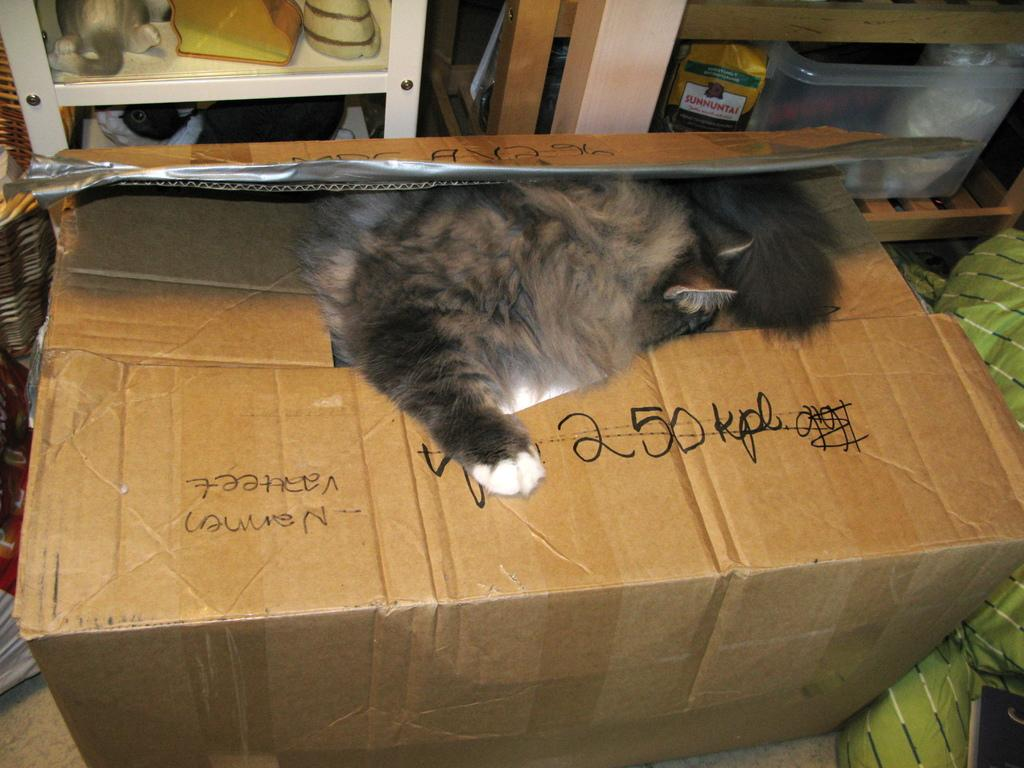<image>
Provide a brief description of the given image. a card board box with a cat on it and writing 250 KPL 